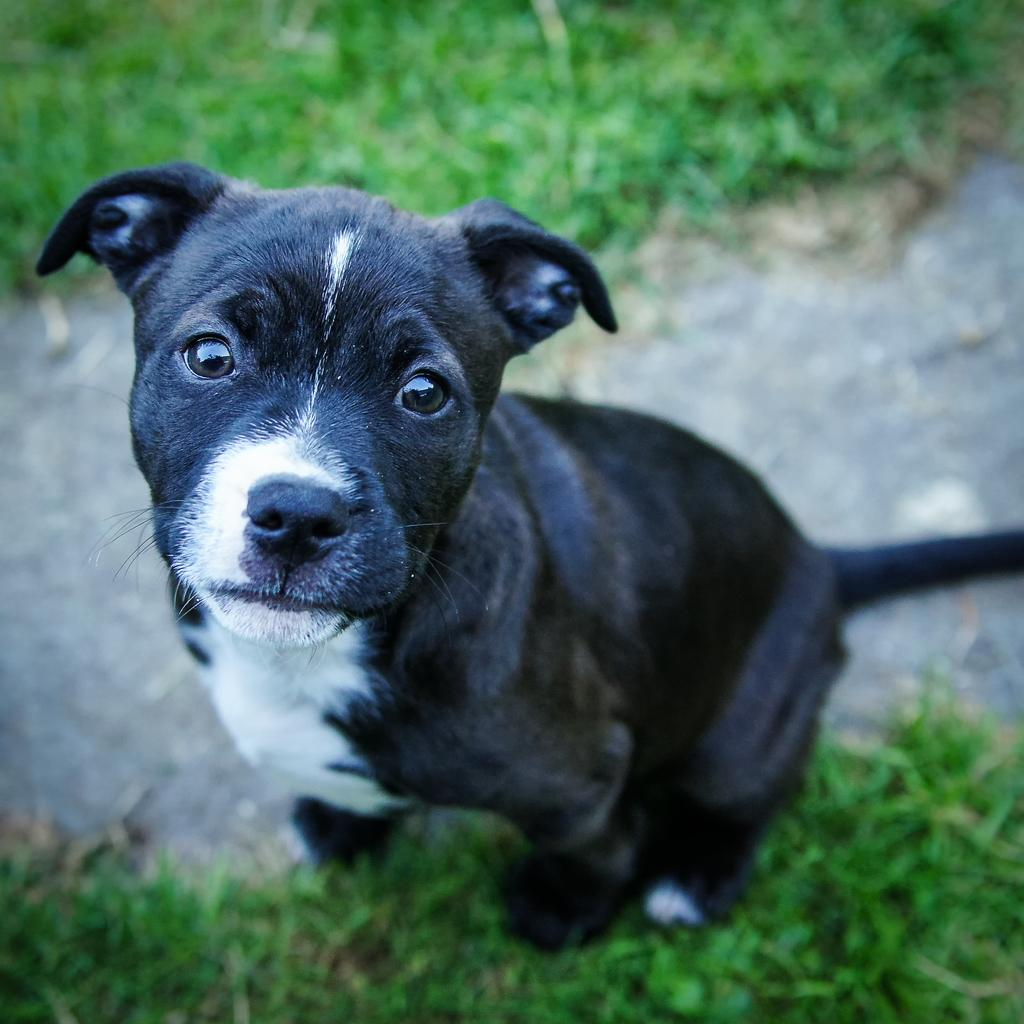What animal can be seen in the image? There is a dog in the image. What is the dog doing in the image? The dog is sitting on the grass. What type of surface is the dog sitting on? There is grass visible in the image. What can be seen in the background of the image? There is a road in the background of the image. What color is the spot on the dog's back in the image? There is no mention of a spot on the dog's back in the provided facts, so we cannot determine its color. 